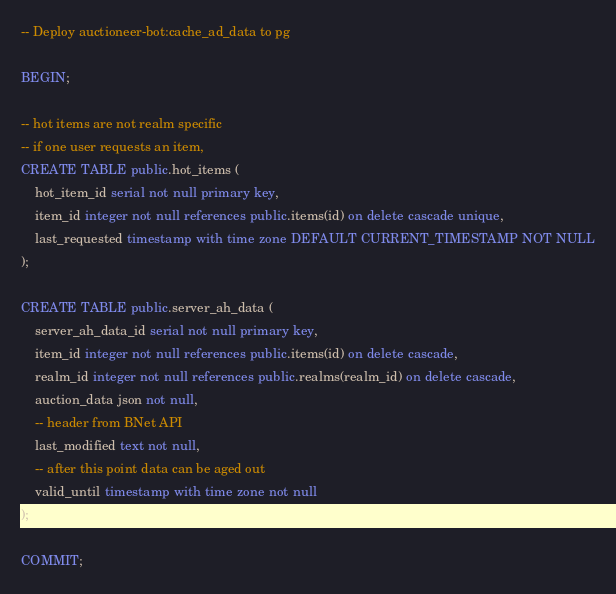<code> <loc_0><loc_0><loc_500><loc_500><_SQL_>-- Deploy auctioneer-bot:cache_ad_data to pg

BEGIN;

-- hot items are not realm specific
-- if one user requests an item,
CREATE TABLE public.hot_items (
    hot_item_id serial not null primary key,
    item_id integer not null references public.items(id) on delete cascade unique,
    last_requested timestamp with time zone DEFAULT CURRENT_TIMESTAMP NOT NULL
);

CREATE TABLE public.server_ah_data (
    server_ah_data_id serial not null primary key,
    item_id integer not null references public.items(id) on delete cascade,
    realm_id integer not null references public.realms(realm_id) on delete cascade,
    auction_data json not null,
    -- header from BNet API
    last_modified text not null,
    -- after this point data can be aged out
    valid_until timestamp with time zone not null
);

COMMIT;
</code> 